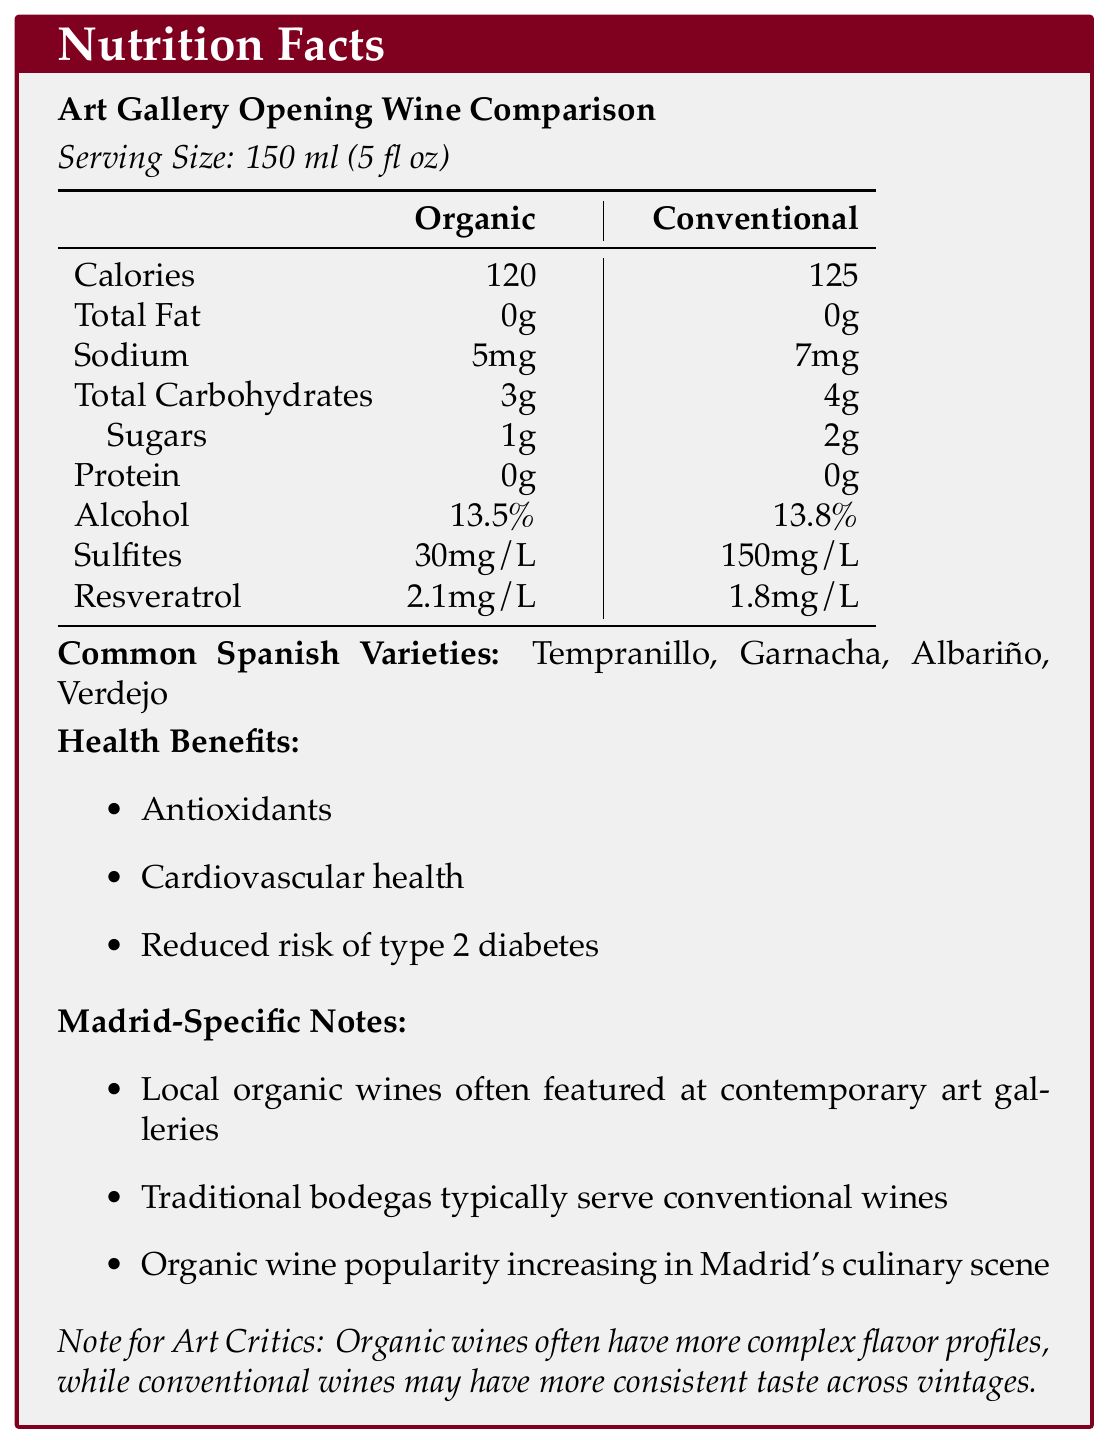what is the serving size? The serving size is stated at the beginning of the Nutrition Facts section.
Answer: 150 ml (5 fl oz) how many calories does a serving of conventional wine contain? The calorie count per serving of conventional wine is listed in the comparative table under the Nutrition Facts section.
Answer: 125 what is the main benefit of organic wines in the context of an art gallery? Refer to the "considerations for art critics" section which mentions that the lower sulfite content in organic wines may reduce headaches.
Answer: Lower sulfite content may reduce headaches how much alcohol does organic wine contain? The alcohol content for organic wine is listed in the comparative table under the Nutrition Facts section.
Answer: 13.5% which parameter has the highest difference between organic and conventional wines? Organic wine contains 30mg/L sulfites while conventional wine contains 150mg/L, showing the largest difference.
Answer: Sulfites which wines are commonly featured at contemporary art galleries in Madrid? A. Conventional Branded Wines B. Local Organic Wines C. International Wines D. Homemade Wines The "Madrid-Specific Notes" section mentions that local organic wines are often featured at contemporary art galleries.
Answer: B which of the following wines has a higher amount of resveratrol? i. Organic ii. Conventional iii. Neither iv. Both The resveratrol content is higher in organic wine (2.1mg/L) compared to conventional wine (1.8mg/L) as stated in the comparative table.
Answer: i does conventional wine have protein? The protein content for both wines is 0g as listed in the Nutrition Facts table.
Answer: No can the total amount of alcohol in a 750 ml bottle of organic wine be determined from the information given? A 750 ml bottle (5 servings of 150 ml each) contains 13.5% alcohol.
Answer: Yes summarize the main points of the document. This summary captures the essence of the document, focusing on the comparison between organic and conventional wines, their nutritional content, health benefits, and cultural context in Madrid.
Answer: The document compares the nutrition facts of organic and conventional wines often featured at art gallery openings. It highlights key differences in calories, sodium, carbs, sugars, alcohol, sulfites, and resveratrol. The potential health benefits, common varieties, popular producers, and specific notes for Madrid are also discussed. how many grams of sugars are in a serving of conventional wine? The sugar content in a serving of conventional wine is listed as 2 grams in the Nutrition Facts table.
Answer: 2g does the document specify antioxidant benefits for organic wine only? The health benefits such as antioxidants apply to wines in general, not just organic or conventional specifically.
Answer: No which wine producer is not listed as a popular organic producer? i. Dominio de Punctum ii. Marqués de Riscal iii. Finca Torremilanos Marqués de Riscal is listed under popular conventional producers, not organic producers.
Answer: ii how can someone identify which types of wines are commonly available in Madrid's art galleries? Information on the common availability of organic and conventional wines in Madrid's art galleries is provided in the "Madrid-Specific Notes" section.
Answer: Refer to the "Madrid-Specific Notes" section what is the reason for conventional wines having more consistent taste across vintages? The document only states that conventional wines may have more consistent taste across vintages without providing a specific reason.
Answer: Not enough information 